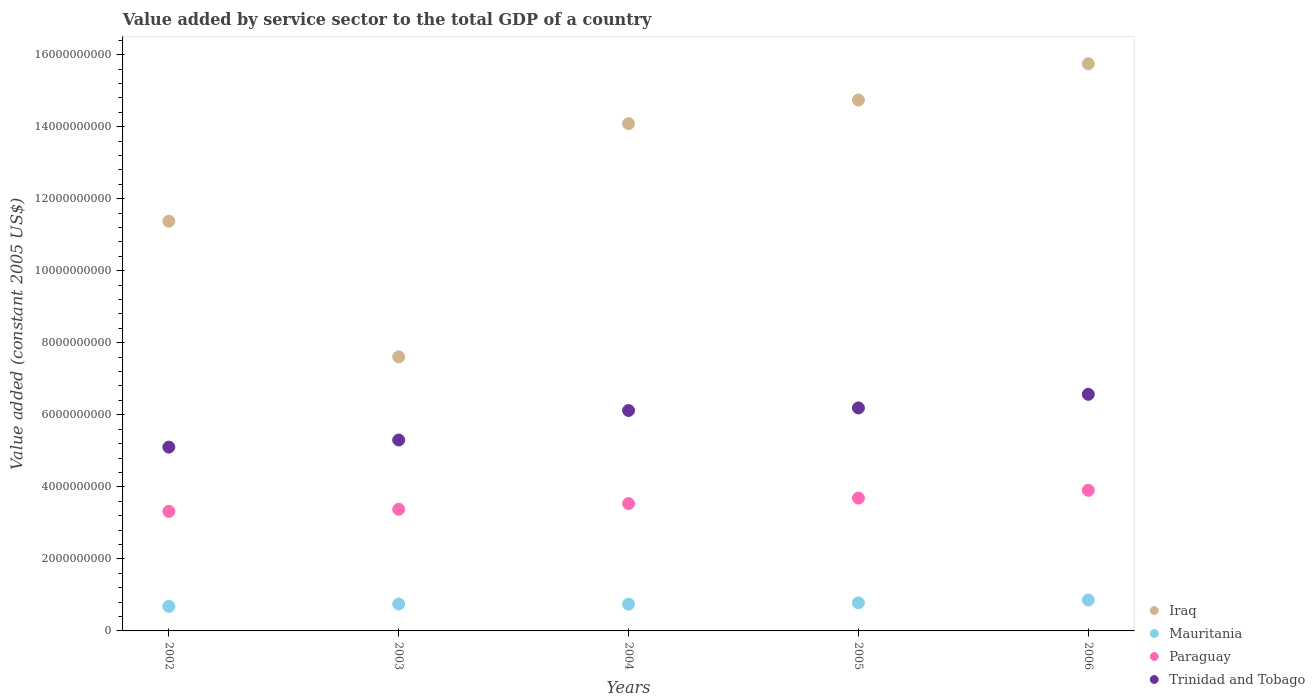How many different coloured dotlines are there?
Keep it short and to the point. 4. What is the value added by service sector in Trinidad and Tobago in 2006?
Ensure brevity in your answer.  6.57e+09. Across all years, what is the maximum value added by service sector in Trinidad and Tobago?
Ensure brevity in your answer.  6.57e+09. Across all years, what is the minimum value added by service sector in Iraq?
Keep it short and to the point. 7.61e+09. In which year was the value added by service sector in Trinidad and Tobago maximum?
Ensure brevity in your answer.  2006. What is the total value added by service sector in Trinidad and Tobago in the graph?
Offer a terse response. 2.93e+1. What is the difference between the value added by service sector in Trinidad and Tobago in 2003 and that in 2004?
Make the answer very short. -8.19e+08. What is the difference between the value added by service sector in Trinidad and Tobago in 2002 and the value added by service sector in Paraguay in 2005?
Keep it short and to the point. 1.41e+09. What is the average value added by service sector in Mauritania per year?
Ensure brevity in your answer.  7.62e+08. In the year 2006, what is the difference between the value added by service sector in Mauritania and value added by service sector in Iraq?
Your answer should be compact. -1.49e+1. What is the ratio of the value added by service sector in Paraguay in 2002 to that in 2004?
Offer a very short reply. 0.94. What is the difference between the highest and the second highest value added by service sector in Mauritania?
Offer a very short reply. 7.91e+07. What is the difference between the highest and the lowest value added by service sector in Paraguay?
Offer a terse response. 5.85e+08. Does the value added by service sector in Trinidad and Tobago monotonically increase over the years?
Offer a terse response. Yes. What is the difference between two consecutive major ticks on the Y-axis?
Offer a terse response. 2.00e+09. Does the graph contain any zero values?
Provide a succinct answer. No. Does the graph contain grids?
Make the answer very short. No. How many legend labels are there?
Give a very brief answer. 4. How are the legend labels stacked?
Keep it short and to the point. Vertical. What is the title of the graph?
Your response must be concise. Value added by service sector to the total GDP of a country. What is the label or title of the Y-axis?
Offer a very short reply. Value added (constant 2005 US$). What is the Value added (constant 2005 US$) of Iraq in 2002?
Provide a short and direct response. 1.14e+1. What is the Value added (constant 2005 US$) in Mauritania in 2002?
Provide a short and direct response. 6.81e+08. What is the Value added (constant 2005 US$) in Paraguay in 2002?
Provide a short and direct response. 3.32e+09. What is the Value added (constant 2005 US$) in Trinidad and Tobago in 2002?
Provide a succinct answer. 5.10e+09. What is the Value added (constant 2005 US$) in Iraq in 2003?
Provide a succinct answer. 7.61e+09. What is the Value added (constant 2005 US$) in Mauritania in 2003?
Make the answer very short. 7.47e+08. What is the Value added (constant 2005 US$) in Paraguay in 2003?
Offer a very short reply. 3.38e+09. What is the Value added (constant 2005 US$) in Trinidad and Tobago in 2003?
Give a very brief answer. 5.30e+09. What is the Value added (constant 2005 US$) of Iraq in 2004?
Give a very brief answer. 1.41e+1. What is the Value added (constant 2005 US$) in Mauritania in 2004?
Offer a terse response. 7.43e+08. What is the Value added (constant 2005 US$) in Paraguay in 2004?
Your response must be concise. 3.53e+09. What is the Value added (constant 2005 US$) of Trinidad and Tobago in 2004?
Make the answer very short. 6.12e+09. What is the Value added (constant 2005 US$) in Iraq in 2005?
Give a very brief answer. 1.47e+1. What is the Value added (constant 2005 US$) in Mauritania in 2005?
Keep it short and to the point. 7.79e+08. What is the Value added (constant 2005 US$) in Paraguay in 2005?
Ensure brevity in your answer.  3.69e+09. What is the Value added (constant 2005 US$) of Trinidad and Tobago in 2005?
Your answer should be compact. 6.19e+09. What is the Value added (constant 2005 US$) of Iraq in 2006?
Your response must be concise. 1.57e+1. What is the Value added (constant 2005 US$) of Mauritania in 2006?
Your response must be concise. 8.58e+08. What is the Value added (constant 2005 US$) of Paraguay in 2006?
Provide a short and direct response. 3.90e+09. What is the Value added (constant 2005 US$) of Trinidad and Tobago in 2006?
Ensure brevity in your answer.  6.57e+09. Across all years, what is the maximum Value added (constant 2005 US$) of Iraq?
Provide a succinct answer. 1.57e+1. Across all years, what is the maximum Value added (constant 2005 US$) of Mauritania?
Your answer should be very brief. 8.58e+08. Across all years, what is the maximum Value added (constant 2005 US$) in Paraguay?
Your answer should be very brief. 3.90e+09. Across all years, what is the maximum Value added (constant 2005 US$) in Trinidad and Tobago?
Provide a short and direct response. 6.57e+09. Across all years, what is the minimum Value added (constant 2005 US$) of Iraq?
Provide a short and direct response. 7.61e+09. Across all years, what is the minimum Value added (constant 2005 US$) in Mauritania?
Keep it short and to the point. 6.81e+08. Across all years, what is the minimum Value added (constant 2005 US$) in Paraguay?
Offer a terse response. 3.32e+09. Across all years, what is the minimum Value added (constant 2005 US$) of Trinidad and Tobago?
Make the answer very short. 5.10e+09. What is the total Value added (constant 2005 US$) of Iraq in the graph?
Offer a terse response. 6.36e+1. What is the total Value added (constant 2005 US$) in Mauritania in the graph?
Your answer should be compact. 3.81e+09. What is the total Value added (constant 2005 US$) of Paraguay in the graph?
Ensure brevity in your answer.  1.78e+1. What is the total Value added (constant 2005 US$) of Trinidad and Tobago in the graph?
Make the answer very short. 2.93e+1. What is the difference between the Value added (constant 2005 US$) in Iraq in 2002 and that in 2003?
Provide a succinct answer. 3.76e+09. What is the difference between the Value added (constant 2005 US$) in Mauritania in 2002 and that in 2003?
Your response must be concise. -6.63e+07. What is the difference between the Value added (constant 2005 US$) of Paraguay in 2002 and that in 2003?
Your response must be concise. -5.89e+07. What is the difference between the Value added (constant 2005 US$) in Trinidad and Tobago in 2002 and that in 2003?
Keep it short and to the point. -1.98e+08. What is the difference between the Value added (constant 2005 US$) of Iraq in 2002 and that in 2004?
Provide a succinct answer. -2.71e+09. What is the difference between the Value added (constant 2005 US$) of Mauritania in 2002 and that in 2004?
Give a very brief answer. -6.20e+07. What is the difference between the Value added (constant 2005 US$) of Paraguay in 2002 and that in 2004?
Ensure brevity in your answer.  -2.17e+08. What is the difference between the Value added (constant 2005 US$) in Trinidad and Tobago in 2002 and that in 2004?
Keep it short and to the point. -1.02e+09. What is the difference between the Value added (constant 2005 US$) of Iraq in 2002 and that in 2005?
Your answer should be compact. -3.36e+09. What is the difference between the Value added (constant 2005 US$) in Mauritania in 2002 and that in 2005?
Your answer should be very brief. -9.81e+07. What is the difference between the Value added (constant 2005 US$) of Paraguay in 2002 and that in 2005?
Offer a very short reply. -3.70e+08. What is the difference between the Value added (constant 2005 US$) of Trinidad and Tobago in 2002 and that in 2005?
Provide a short and direct response. -1.09e+09. What is the difference between the Value added (constant 2005 US$) in Iraq in 2002 and that in 2006?
Your response must be concise. -4.37e+09. What is the difference between the Value added (constant 2005 US$) in Mauritania in 2002 and that in 2006?
Provide a succinct answer. -1.77e+08. What is the difference between the Value added (constant 2005 US$) in Paraguay in 2002 and that in 2006?
Your answer should be compact. -5.85e+08. What is the difference between the Value added (constant 2005 US$) of Trinidad and Tobago in 2002 and that in 2006?
Provide a short and direct response. -1.47e+09. What is the difference between the Value added (constant 2005 US$) in Iraq in 2003 and that in 2004?
Provide a short and direct response. -6.47e+09. What is the difference between the Value added (constant 2005 US$) of Mauritania in 2003 and that in 2004?
Give a very brief answer. 4.30e+06. What is the difference between the Value added (constant 2005 US$) in Paraguay in 2003 and that in 2004?
Keep it short and to the point. -1.58e+08. What is the difference between the Value added (constant 2005 US$) in Trinidad and Tobago in 2003 and that in 2004?
Provide a short and direct response. -8.19e+08. What is the difference between the Value added (constant 2005 US$) of Iraq in 2003 and that in 2005?
Provide a short and direct response. -7.13e+09. What is the difference between the Value added (constant 2005 US$) of Mauritania in 2003 and that in 2005?
Provide a succinct answer. -3.18e+07. What is the difference between the Value added (constant 2005 US$) of Paraguay in 2003 and that in 2005?
Ensure brevity in your answer.  -3.11e+08. What is the difference between the Value added (constant 2005 US$) of Trinidad and Tobago in 2003 and that in 2005?
Your answer should be compact. -8.91e+08. What is the difference between the Value added (constant 2005 US$) in Iraq in 2003 and that in 2006?
Provide a succinct answer. -8.14e+09. What is the difference between the Value added (constant 2005 US$) of Mauritania in 2003 and that in 2006?
Your answer should be compact. -1.11e+08. What is the difference between the Value added (constant 2005 US$) of Paraguay in 2003 and that in 2006?
Your answer should be very brief. -5.26e+08. What is the difference between the Value added (constant 2005 US$) in Trinidad and Tobago in 2003 and that in 2006?
Your answer should be compact. -1.27e+09. What is the difference between the Value added (constant 2005 US$) of Iraq in 2004 and that in 2005?
Provide a succinct answer. -6.56e+08. What is the difference between the Value added (constant 2005 US$) in Mauritania in 2004 and that in 2005?
Provide a short and direct response. -3.61e+07. What is the difference between the Value added (constant 2005 US$) of Paraguay in 2004 and that in 2005?
Your response must be concise. -1.53e+08. What is the difference between the Value added (constant 2005 US$) in Trinidad and Tobago in 2004 and that in 2005?
Give a very brief answer. -7.18e+07. What is the difference between the Value added (constant 2005 US$) of Iraq in 2004 and that in 2006?
Keep it short and to the point. -1.66e+09. What is the difference between the Value added (constant 2005 US$) of Mauritania in 2004 and that in 2006?
Offer a very short reply. -1.15e+08. What is the difference between the Value added (constant 2005 US$) of Paraguay in 2004 and that in 2006?
Make the answer very short. -3.68e+08. What is the difference between the Value added (constant 2005 US$) of Trinidad and Tobago in 2004 and that in 2006?
Make the answer very short. -4.49e+08. What is the difference between the Value added (constant 2005 US$) of Iraq in 2005 and that in 2006?
Your answer should be very brief. -1.01e+09. What is the difference between the Value added (constant 2005 US$) in Mauritania in 2005 and that in 2006?
Offer a terse response. -7.91e+07. What is the difference between the Value added (constant 2005 US$) of Paraguay in 2005 and that in 2006?
Your response must be concise. -2.15e+08. What is the difference between the Value added (constant 2005 US$) of Trinidad and Tobago in 2005 and that in 2006?
Provide a short and direct response. -3.77e+08. What is the difference between the Value added (constant 2005 US$) of Iraq in 2002 and the Value added (constant 2005 US$) of Mauritania in 2003?
Your answer should be compact. 1.06e+1. What is the difference between the Value added (constant 2005 US$) of Iraq in 2002 and the Value added (constant 2005 US$) of Paraguay in 2003?
Offer a terse response. 8.00e+09. What is the difference between the Value added (constant 2005 US$) in Iraq in 2002 and the Value added (constant 2005 US$) in Trinidad and Tobago in 2003?
Provide a succinct answer. 6.07e+09. What is the difference between the Value added (constant 2005 US$) of Mauritania in 2002 and the Value added (constant 2005 US$) of Paraguay in 2003?
Offer a very short reply. -2.70e+09. What is the difference between the Value added (constant 2005 US$) of Mauritania in 2002 and the Value added (constant 2005 US$) of Trinidad and Tobago in 2003?
Offer a terse response. -4.62e+09. What is the difference between the Value added (constant 2005 US$) in Paraguay in 2002 and the Value added (constant 2005 US$) in Trinidad and Tobago in 2003?
Your response must be concise. -1.98e+09. What is the difference between the Value added (constant 2005 US$) in Iraq in 2002 and the Value added (constant 2005 US$) in Mauritania in 2004?
Your answer should be compact. 1.06e+1. What is the difference between the Value added (constant 2005 US$) of Iraq in 2002 and the Value added (constant 2005 US$) of Paraguay in 2004?
Keep it short and to the point. 7.84e+09. What is the difference between the Value added (constant 2005 US$) of Iraq in 2002 and the Value added (constant 2005 US$) of Trinidad and Tobago in 2004?
Make the answer very short. 5.26e+09. What is the difference between the Value added (constant 2005 US$) in Mauritania in 2002 and the Value added (constant 2005 US$) in Paraguay in 2004?
Your response must be concise. -2.85e+09. What is the difference between the Value added (constant 2005 US$) in Mauritania in 2002 and the Value added (constant 2005 US$) in Trinidad and Tobago in 2004?
Provide a succinct answer. -5.44e+09. What is the difference between the Value added (constant 2005 US$) of Paraguay in 2002 and the Value added (constant 2005 US$) of Trinidad and Tobago in 2004?
Offer a very short reply. -2.80e+09. What is the difference between the Value added (constant 2005 US$) of Iraq in 2002 and the Value added (constant 2005 US$) of Mauritania in 2005?
Offer a very short reply. 1.06e+1. What is the difference between the Value added (constant 2005 US$) of Iraq in 2002 and the Value added (constant 2005 US$) of Paraguay in 2005?
Your answer should be compact. 7.69e+09. What is the difference between the Value added (constant 2005 US$) in Iraq in 2002 and the Value added (constant 2005 US$) in Trinidad and Tobago in 2005?
Provide a succinct answer. 5.18e+09. What is the difference between the Value added (constant 2005 US$) in Mauritania in 2002 and the Value added (constant 2005 US$) in Paraguay in 2005?
Offer a terse response. -3.01e+09. What is the difference between the Value added (constant 2005 US$) in Mauritania in 2002 and the Value added (constant 2005 US$) in Trinidad and Tobago in 2005?
Offer a very short reply. -5.51e+09. What is the difference between the Value added (constant 2005 US$) in Paraguay in 2002 and the Value added (constant 2005 US$) in Trinidad and Tobago in 2005?
Make the answer very short. -2.87e+09. What is the difference between the Value added (constant 2005 US$) in Iraq in 2002 and the Value added (constant 2005 US$) in Mauritania in 2006?
Your answer should be compact. 1.05e+1. What is the difference between the Value added (constant 2005 US$) of Iraq in 2002 and the Value added (constant 2005 US$) of Paraguay in 2006?
Offer a very short reply. 7.47e+09. What is the difference between the Value added (constant 2005 US$) of Iraq in 2002 and the Value added (constant 2005 US$) of Trinidad and Tobago in 2006?
Keep it short and to the point. 4.81e+09. What is the difference between the Value added (constant 2005 US$) of Mauritania in 2002 and the Value added (constant 2005 US$) of Paraguay in 2006?
Provide a short and direct response. -3.22e+09. What is the difference between the Value added (constant 2005 US$) in Mauritania in 2002 and the Value added (constant 2005 US$) in Trinidad and Tobago in 2006?
Ensure brevity in your answer.  -5.89e+09. What is the difference between the Value added (constant 2005 US$) of Paraguay in 2002 and the Value added (constant 2005 US$) of Trinidad and Tobago in 2006?
Make the answer very short. -3.25e+09. What is the difference between the Value added (constant 2005 US$) in Iraq in 2003 and the Value added (constant 2005 US$) in Mauritania in 2004?
Your answer should be compact. 6.87e+09. What is the difference between the Value added (constant 2005 US$) of Iraq in 2003 and the Value added (constant 2005 US$) of Paraguay in 2004?
Keep it short and to the point. 4.07e+09. What is the difference between the Value added (constant 2005 US$) of Iraq in 2003 and the Value added (constant 2005 US$) of Trinidad and Tobago in 2004?
Provide a succinct answer. 1.49e+09. What is the difference between the Value added (constant 2005 US$) of Mauritania in 2003 and the Value added (constant 2005 US$) of Paraguay in 2004?
Your answer should be compact. -2.79e+09. What is the difference between the Value added (constant 2005 US$) in Mauritania in 2003 and the Value added (constant 2005 US$) in Trinidad and Tobago in 2004?
Provide a short and direct response. -5.37e+09. What is the difference between the Value added (constant 2005 US$) in Paraguay in 2003 and the Value added (constant 2005 US$) in Trinidad and Tobago in 2004?
Your answer should be very brief. -2.74e+09. What is the difference between the Value added (constant 2005 US$) of Iraq in 2003 and the Value added (constant 2005 US$) of Mauritania in 2005?
Offer a terse response. 6.83e+09. What is the difference between the Value added (constant 2005 US$) of Iraq in 2003 and the Value added (constant 2005 US$) of Paraguay in 2005?
Give a very brief answer. 3.92e+09. What is the difference between the Value added (constant 2005 US$) of Iraq in 2003 and the Value added (constant 2005 US$) of Trinidad and Tobago in 2005?
Keep it short and to the point. 1.42e+09. What is the difference between the Value added (constant 2005 US$) of Mauritania in 2003 and the Value added (constant 2005 US$) of Paraguay in 2005?
Provide a succinct answer. -2.94e+09. What is the difference between the Value added (constant 2005 US$) of Mauritania in 2003 and the Value added (constant 2005 US$) of Trinidad and Tobago in 2005?
Your response must be concise. -5.44e+09. What is the difference between the Value added (constant 2005 US$) of Paraguay in 2003 and the Value added (constant 2005 US$) of Trinidad and Tobago in 2005?
Give a very brief answer. -2.81e+09. What is the difference between the Value added (constant 2005 US$) in Iraq in 2003 and the Value added (constant 2005 US$) in Mauritania in 2006?
Offer a terse response. 6.75e+09. What is the difference between the Value added (constant 2005 US$) in Iraq in 2003 and the Value added (constant 2005 US$) in Paraguay in 2006?
Keep it short and to the point. 3.71e+09. What is the difference between the Value added (constant 2005 US$) in Iraq in 2003 and the Value added (constant 2005 US$) in Trinidad and Tobago in 2006?
Give a very brief answer. 1.04e+09. What is the difference between the Value added (constant 2005 US$) of Mauritania in 2003 and the Value added (constant 2005 US$) of Paraguay in 2006?
Your answer should be very brief. -3.16e+09. What is the difference between the Value added (constant 2005 US$) of Mauritania in 2003 and the Value added (constant 2005 US$) of Trinidad and Tobago in 2006?
Give a very brief answer. -5.82e+09. What is the difference between the Value added (constant 2005 US$) of Paraguay in 2003 and the Value added (constant 2005 US$) of Trinidad and Tobago in 2006?
Your answer should be very brief. -3.19e+09. What is the difference between the Value added (constant 2005 US$) in Iraq in 2004 and the Value added (constant 2005 US$) in Mauritania in 2005?
Provide a succinct answer. 1.33e+1. What is the difference between the Value added (constant 2005 US$) of Iraq in 2004 and the Value added (constant 2005 US$) of Paraguay in 2005?
Provide a succinct answer. 1.04e+1. What is the difference between the Value added (constant 2005 US$) of Iraq in 2004 and the Value added (constant 2005 US$) of Trinidad and Tobago in 2005?
Offer a very short reply. 7.89e+09. What is the difference between the Value added (constant 2005 US$) in Mauritania in 2004 and the Value added (constant 2005 US$) in Paraguay in 2005?
Make the answer very short. -2.95e+09. What is the difference between the Value added (constant 2005 US$) in Mauritania in 2004 and the Value added (constant 2005 US$) in Trinidad and Tobago in 2005?
Ensure brevity in your answer.  -5.45e+09. What is the difference between the Value added (constant 2005 US$) of Paraguay in 2004 and the Value added (constant 2005 US$) of Trinidad and Tobago in 2005?
Your response must be concise. -2.66e+09. What is the difference between the Value added (constant 2005 US$) in Iraq in 2004 and the Value added (constant 2005 US$) in Mauritania in 2006?
Make the answer very short. 1.32e+1. What is the difference between the Value added (constant 2005 US$) of Iraq in 2004 and the Value added (constant 2005 US$) of Paraguay in 2006?
Keep it short and to the point. 1.02e+1. What is the difference between the Value added (constant 2005 US$) of Iraq in 2004 and the Value added (constant 2005 US$) of Trinidad and Tobago in 2006?
Give a very brief answer. 7.51e+09. What is the difference between the Value added (constant 2005 US$) of Mauritania in 2004 and the Value added (constant 2005 US$) of Paraguay in 2006?
Your response must be concise. -3.16e+09. What is the difference between the Value added (constant 2005 US$) of Mauritania in 2004 and the Value added (constant 2005 US$) of Trinidad and Tobago in 2006?
Your response must be concise. -5.83e+09. What is the difference between the Value added (constant 2005 US$) of Paraguay in 2004 and the Value added (constant 2005 US$) of Trinidad and Tobago in 2006?
Your answer should be compact. -3.03e+09. What is the difference between the Value added (constant 2005 US$) in Iraq in 2005 and the Value added (constant 2005 US$) in Mauritania in 2006?
Make the answer very short. 1.39e+1. What is the difference between the Value added (constant 2005 US$) of Iraq in 2005 and the Value added (constant 2005 US$) of Paraguay in 2006?
Make the answer very short. 1.08e+1. What is the difference between the Value added (constant 2005 US$) of Iraq in 2005 and the Value added (constant 2005 US$) of Trinidad and Tobago in 2006?
Ensure brevity in your answer.  8.17e+09. What is the difference between the Value added (constant 2005 US$) of Mauritania in 2005 and the Value added (constant 2005 US$) of Paraguay in 2006?
Make the answer very short. -3.12e+09. What is the difference between the Value added (constant 2005 US$) of Mauritania in 2005 and the Value added (constant 2005 US$) of Trinidad and Tobago in 2006?
Make the answer very short. -5.79e+09. What is the difference between the Value added (constant 2005 US$) of Paraguay in 2005 and the Value added (constant 2005 US$) of Trinidad and Tobago in 2006?
Your answer should be compact. -2.88e+09. What is the average Value added (constant 2005 US$) of Iraq per year?
Keep it short and to the point. 1.27e+1. What is the average Value added (constant 2005 US$) in Mauritania per year?
Offer a terse response. 7.62e+08. What is the average Value added (constant 2005 US$) in Paraguay per year?
Provide a short and direct response. 3.56e+09. What is the average Value added (constant 2005 US$) of Trinidad and Tobago per year?
Offer a very short reply. 5.86e+09. In the year 2002, what is the difference between the Value added (constant 2005 US$) in Iraq and Value added (constant 2005 US$) in Mauritania?
Keep it short and to the point. 1.07e+1. In the year 2002, what is the difference between the Value added (constant 2005 US$) of Iraq and Value added (constant 2005 US$) of Paraguay?
Your response must be concise. 8.06e+09. In the year 2002, what is the difference between the Value added (constant 2005 US$) of Iraq and Value added (constant 2005 US$) of Trinidad and Tobago?
Offer a very short reply. 6.27e+09. In the year 2002, what is the difference between the Value added (constant 2005 US$) in Mauritania and Value added (constant 2005 US$) in Paraguay?
Provide a succinct answer. -2.64e+09. In the year 2002, what is the difference between the Value added (constant 2005 US$) in Mauritania and Value added (constant 2005 US$) in Trinidad and Tobago?
Keep it short and to the point. -4.42e+09. In the year 2002, what is the difference between the Value added (constant 2005 US$) of Paraguay and Value added (constant 2005 US$) of Trinidad and Tobago?
Offer a terse response. -1.78e+09. In the year 2003, what is the difference between the Value added (constant 2005 US$) in Iraq and Value added (constant 2005 US$) in Mauritania?
Keep it short and to the point. 6.86e+09. In the year 2003, what is the difference between the Value added (constant 2005 US$) of Iraq and Value added (constant 2005 US$) of Paraguay?
Ensure brevity in your answer.  4.23e+09. In the year 2003, what is the difference between the Value added (constant 2005 US$) of Iraq and Value added (constant 2005 US$) of Trinidad and Tobago?
Your answer should be very brief. 2.31e+09. In the year 2003, what is the difference between the Value added (constant 2005 US$) of Mauritania and Value added (constant 2005 US$) of Paraguay?
Keep it short and to the point. -2.63e+09. In the year 2003, what is the difference between the Value added (constant 2005 US$) in Mauritania and Value added (constant 2005 US$) in Trinidad and Tobago?
Your answer should be compact. -4.55e+09. In the year 2003, what is the difference between the Value added (constant 2005 US$) in Paraguay and Value added (constant 2005 US$) in Trinidad and Tobago?
Make the answer very short. -1.92e+09. In the year 2004, what is the difference between the Value added (constant 2005 US$) of Iraq and Value added (constant 2005 US$) of Mauritania?
Give a very brief answer. 1.33e+1. In the year 2004, what is the difference between the Value added (constant 2005 US$) in Iraq and Value added (constant 2005 US$) in Paraguay?
Give a very brief answer. 1.05e+1. In the year 2004, what is the difference between the Value added (constant 2005 US$) in Iraq and Value added (constant 2005 US$) in Trinidad and Tobago?
Your response must be concise. 7.96e+09. In the year 2004, what is the difference between the Value added (constant 2005 US$) in Mauritania and Value added (constant 2005 US$) in Paraguay?
Ensure brevity in your answer.  -2.79e+09. In the year 2004, what is the difference between the Value added (constant 2005 US$) of Mauritania and Value added (constant 2005 US$) of Trinidad and Tobago?
Your response must be concise. -5.38e+09. In the year 2004, what is the difference between the Value added (constant 2005 US$) in Paraguay and Value added (constant 2005 US$) in Trinidad and Tobago?
Ensure brevity in your answer.  -2.58e+09. In the year 2005, what is the difference between the Value added (constant 2005 US$) of Iraq and Value added (constant 2005 US$) of Mauritania?
Ensure brevity in your answer.  1.40e+1. In the year 2005, what is the difference between the Value added (constant 2005 US$) in Iraq and Value added (constant 2005 US$) in Paraguay?
Your answer should be compact. 1.11e+1. In the year 2005, what is the difference between the Value added (constant 2005 US$) of Iraq and Value added (constant 2005 US$) of Trinidad and Tobago?
Your answer should be compact. 8.55e+09. In the year 2005, what is the difference between the Value added (constant 2005 US$) of Mauritania and Value added (constant 2005 US$) of Paraguay?
Your answer should be very brief. -2.91e+09. In the year 2005, what is the difference between the Value added (constant 2005 US$) of Mauritania and Value added (constant 2005 US$) of Trinidad and Tobago?
Give a very brief answer. -5.41e+09. In the year 2005, what is the difference between the Value added (constant 2005 US$) of Paraguay and Value added (constant 2005 US$) of Trinidad and Tobago?
Offer a very short reply. -2.50e+09. In the year 2006, what is the difference between the Value added (constant 2005 US$) in Iraq and Value added (constant 2005 US$) in Mauritania?
Ensure brevity in your answer.  1.49e+1. In the year 2006, what is the difference between the Value added (constant 2005 US$) of Iraq and Value added (constant 2005 US$) of Paraguay?
Offer a terse response. 1.18e+1. In the year 2006, what is the difference between the Value added (constant 2005 US$) of Iraq and Value added (constant 2005 US$) of Trinidad and Tobago?
Your answer should be very brief. 9.18e+09. In the year 2006, what is the difference between the Value added (constant 2005 US$) of Mauritania and Value added (constant 2005 US$) of Paraguay?
Provide a short and direct response. -3.04e+09. In the year 2006, what is the difference between the Value added (constant 2005 US$) of Mauritania and Value added (constant 2005 US$) of Trinidad and Tobago?
Offer a terse response. -5.71e+09. In the year 2006, what is the difference between the Value added (constant 2005 US$) in Paraguay and Value added (constant 2005 US$) in Trinidad and Tobago?
Ensure brevity in your answer.  -2.67e+09. What is the ratio of the Value added (constant 2005 US$) of Iraq in 2002 to that in 2003?
Offer a very short reply. 1.49. What is the ratio of the Value added (constant 2005 US$) in Mauritania in 2002 to that in 2003?
Keep it short and to the point. 0.91. What is the ratio of the Value added (constant 2005 US$) in Paraguay in 2002 to that in 2003?
Ensure brevity in your answer.  0.98. What is the ratio of the Value added (constant 2005 US$) of Trinidad and Tobago in 2002 to that in 2003?
Your answer should be compact. 0.96. What is the ratio of the Value added (constant 2005 US$) in Iraq in 2002 to that in 2004?
Give a very brief answer. 0.81. What is the ratio of the Value added (constant 2005 US$) of Mauritania in 2002 to that in 2004?
Provide a succinct answer. 0.92. What is the ratio of the Value added (constant 2005 US$) in Paraguay in 2002 to that in 2004?
Your answer should be very brief. 0.94. What is the ratio of the Value added (constant 2005 US$) in Trinidad and Tobago in 2002 to that in 2004?
Ensure brevity in your answer.  0.83. What is the ratio of the Value added (constant 2005 US$) in Iraq in 2002 to that in 2005?
Your answer should be very brief. 0.77. What is the ratio of the Value added (constant 2005 US$) in Mauritania in 2002 to that in 2005?
Give a very brief answer. 0.87. What is the ratio of the Value added (constant 2005 US$) of Paraguay in 2002 to that in 2005?
Offer a very short reply. 0.9. What is the ratio of the Value added (constant 2005 US$) in Trinidad and Tobago in 2002 to that in 2005?
Offer a terse response. 0.82. What is the ratio of the Value added (constant 2005 US$) of Iraq in 2002 to that in 2006?
Give a very brief answer. 0.72. What is the ratio of the Value added (constant 2005 US$) of Mauritania in 2002 to that in 2006?
Your response must be concise. 0.79. What is the ratio of the Value added (constant 2005 US$) in Paraguay in 2002 to that in 2006?
Give a very brief answer. 0.85. What is the ratio of the Value added (constant 2005 US$) in Trinidad and Tobago in 2002 to that in 2006?
Ensure brevity in your answer.  0.78. What is the ratio of the Value added (constant 2005 US$) in Iraq in 2003 to that in 2004?
Offer a terse response. 0.54. What is the ratio of the Value added (constant 2005 US$) of Paraguay in 2003 to that in 2004?
Ensure brevity in your answer.  0.96. What is the ratio of the Value added (constant 2005 US$) of Trinidad and Tobago in 2003 to that in 2004?
Your answer should be compact. 0.87. What is the ratio of the Value added (constant 2005 US$) of Iraq in 2003 to that in 2005?
Your answer should be compact. 0.52. What is the ratio of the Value added (constant 2005 US$) in Mauritania in 2003 to that in 2005?
Your answer should be very brief. 0.96. What is the ratio of the Value added (constant 2005 US$) of Paraguay in 2003 to that in 2005?
Provide a short and direct response. 0.92. What is the ratio of the Value added (constant 2005 US$) in Trinidad and Tobago in 2003 to that in 2005?
Give a very brief answer. 0.86. What is the ratio of the Value added (constant 2005 US$) in Iraq in 2003 to that in 2006?
Keep it short and to the point. 0.48. What is the ratio of the Value added (constant 2005 US$) of Mauritania in 2003 to that in 2006?
Your answer should be compact. 0.87. What is the ratio of the Value added (constant 2005 US$) of Paraguay in 2003 to that in 2006?
Give a very brief answer. 0.87. What is the ratio of the Value added (constant 2005 US$) in Trinidad and Tobago in 2003 to that in 2006?
Give a very brief answer. 0.81. What is the ratio of the Value added (constant 2005 US$) in Iraq in 2004 to that in 2005?
Ensure brevity in your answer.  0.96. What is the ratio of the Value added (constant 2005 US$) in Mauritania in 2004 to that in 2005?
Give a very brief answer. 0.95. What is the ratio of the Value added (constant 2005 US$) of Paraguay in 2004 to that in 2005?
Ensure brevity in your answer.  0.96. What is the ratio of the Value added (constant 2005 US$) of Trinidad and Tobago in 2004 to that in 2005?
Make the answer very short. 0.99. What is the ratio of the Value added (constant 2005 US$) of Iraq in 2004 to that in 2006?
Provide a short and direct response. 0.89. What is the ratio of the Value added (constant 2005 US$) in Mauritania in 2004 to that in 2006?
Your answer should be very brief. 0.87. What is the ratio of the Value added (constant 2005 US$) of Paraguay in 2004 to that in 2006?
Offer a terse response. 0.91. What is the ratio of the Value added (constant 2005 US$) in Trinidad and Tobago in 2004 to that in 2006?
Your response must be concise. 0.93. What is the ratio of the Value added (constant 2005 US$) of Iraq in 2005 to that in 2006?
Keep it short and to the point. 0.94. What is the ratio of the Value added (constant 2005 US$) in Mauritania in 2005 to that in 2006?
Provide a short and direct response. 0.91. What is the ratio of the Value added (constant 2005 US$) in Paraguay in 2005 to that in 2006?
Provide a succinct answer. 0.94. What is the ratio of the Value added (constant 2005 US$) in Trinidad and Tobago in 2005 to that in 2006?
Your answer should be compact. 0.94. What is the difference between the highest and the second highest Value added (constant 2005 US$) in Iraq?
Offer a terse response. 1.01e+09. What is the difference between the highest and the second highest Value added (constant 2005 US$) in Mauritania?
Offer a terse response. 7.91e+07. What is the difference between the highest and the second highest Value added (constant 2005 US$) in Paraguay?
Your response must be concise. 2.15e+08. What is the difference between the highest and the second highest Value added (constant 2005 US$) in Trinidad and Tobago?
Offer a terse response. 3.77e+08. What is the difference between the highest and the lowest Value added (constant 2005 US$) in Iraq?
Offer a very short reply. 8.14e+09. What is the difference between the highest and the lowest Value added (constant 2005 US$) of Mauritania?
Your answer should be compact. 1.77e+08. What is the difference between the highest and the lowest Value added (constant 2005 US$) of Paraguay?
Make the answer very short. 5.85e+08. What is the difference between the highest and the lowest Value added (constant 2005 US$) in Trinidad and Tobago?
Keep it short and to the point. 1.47e+09. 